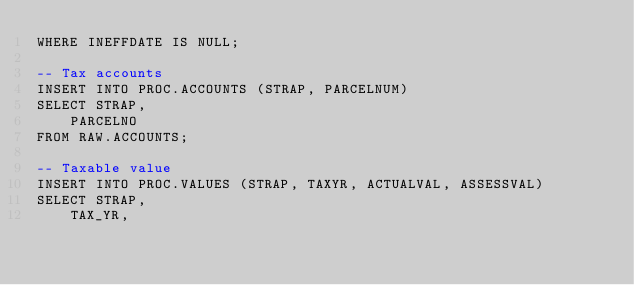Convert code to text. <code><loc_0><loc_0><loc_500><loc_500><_SQL_>WHERE INEFFDATE IS NULL;

-- Tax accounts
INSERT INTO PROC.ACCOUNTS (STRAP, PARCELNUM)
SELECT STRAP,
	PARCELNO
FROM RAW.ACCOUNTS;

-- Taxable value
INSERT INTO PROC.VALUES (STRAP, TAXYR, ACTUALVAL, ASSESSVAL)
SELECT STRAP,
	TAX_YR,</code> 